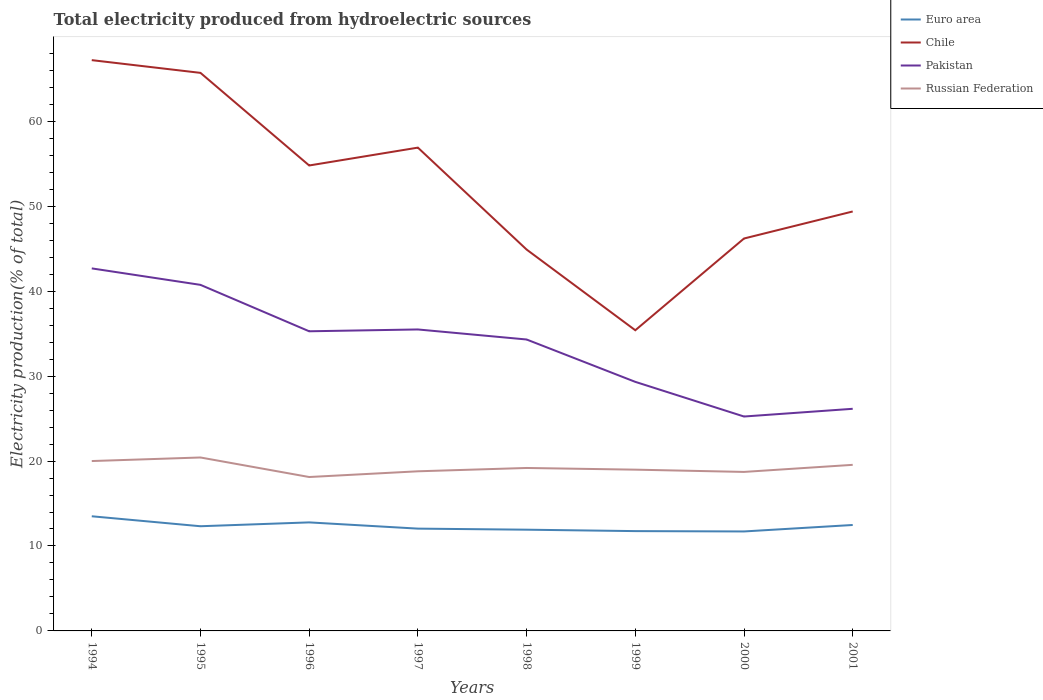How many different coloured lines are there?
Offer a very short reply. 4. Is the number of lines equal to the number of legend labels?
Make the answer very short. Yes. Across all years, what is the maximum total electricity produced in Chile?
Ensure brevity in your answer.  35.4. What is the total total electricity produced in Euro area in the graph?
Your response must be concise. 0.31. What is the difference between the highest and the second highest total electricity produced in Chile?
Keep it short and to the point. 31.8. What is the difference between the highest and the lowest total electricity produced in Pakistan?
Offer a very short reply. 5. Is the total electricity produced in Pakistan strictly greater than the total electricity produced in Euro area over the years?
Your answer should be compact. No. How many lines are there?
Keep it short and to the point. 4. Does the graph contain any zero values?
Keep it short and to the point. No. How many legend labels are there?
Give a very brief answer. 4. What is the title of the graph?
Give a very brief answer. Total electricity produced from hydroelectric sources. What is the label or title of the X-axis?
Ensure brevity in your answer.  Years. What is the label or title of the Y-axis?
Provide a succinct answer. Electricity production(% of total). What is the Electricity production(% of total) in Euro area in 1994?
Make the answer very short. 13.5. What is the Electricity production(% of total) of Chile in 1994?
Offer a very short reply. 67.2. What is the Electricity production(% of total) in Pakistan in 1994?
Keep it short and to the point. 42.68. What is the Electricity production(% of total) of Russian Federation in 1994?
Your answer should be very brief. 20. What is the Electricity production(% of total) in Euro area in 1995?
Offer a very short reply. 12.32. What is the Electricity production(% of total) of Chile in 1995?
Your response must be concise. 65.7. What is the Electricity production(% of total) in Pakistan in 1995?
Your answer should be very brief. 40.74. What is the Electricity production(% of total) in Russian Federation in 1995?
Your response must be concise. 20.42. What is the Electricity production(% of total) in Euro area in 1996?
Keep it short and to the point. 12.78. What is the Electricity production(% of total) of Chile in 1996?
Give a very brief answer. 54.8. What is the Electricity production(% of total) of Pakistan in 1996?
Ensure brevity in your answer.  35.28. What is the Electricity production(% of total) in Russian Federation in 1996?
Your response must be concise. 18.12. What is the Electricity production(% of total) in Euro area in 1997?
Provide a short and direct response. 12.04. What is the Electricity production(% of total) in Chile in 1997?
Your answer should be very brief. 56.9. What is the Electricity production(% of total) of Pakistan in 1997?
Ensure brevity in your answer.  35.49. What is the Electricity production(% of total) in Russian Federation in 1997?
Offer a terse response. 18.79. What is the Electricity production(% of total) of Euro area in 1998?
Offer a very short reply. 11.92. What is the Electricity production(% of total) in Chile in 1998?
Provide a short and direct response. 44.9. What is the Electricity production(% of total) of Pakistan in 1998?
Provide a short and direct response. 34.31. What is the Electricity production(% of total) of Russian Federation in 1998?
Offer a terse response. 19.18. What is the Electricity production(% of total) of Euro area in 1999?
Your answer should be very brief. 11.75. What is the Electricity production(% of total) of Chile in 1999?
Ensure brevity in your answer.  35.4. What is the Electricity production(% of total) of Pakistan in 1999?
Your response must be concise. 29.32. What is the Electricity production(% of total) of Russian Federation in 1999?
Ensure brevity in your answer.  18.99. What is the Electricity production(% of total) in Euro area in 2000?
Offer a terse response. 11.71. What is the Electricity production(% of total) of Chile in 2000?
Provide a succinct answer. 46.2. What is the Electricity production(% of total) in Pakistan in 2000?
Give a very brief answer. 25.24. What is the Electricity production(% of total) in Russian Federation in 2000?
Your answer should be compact. 18.72. What is the Electricity production(% of total) of Euro area in 2001?
Offer a very short reply. 12.47. What is the Electricity production(% of total) in Chile in 2001?
Make the answer very short. 49.38. What is the Electricity production(% of total) of Pakistan in 2001?
Provide a short and direct response. 26.15. What is the Electricity production(% of total) in Russian Federation in 2001?
Give a very brief answer. 19.55. Across all years, what is the maximum Electricity production(% of total) of Euro area?
Keep it short and to the point. 13.5. Across all years, what is the maximum Electricity production(% of total) in Chile?
Provide a succinct answer. 67.2. Across all years, what is the maximum Electricity production(% of total) of Pakistan?
Offer a terse response. 42.68. Across all years, what is the maximum Electricity production(% of total) of Russian Federation?
Ensure brevity in your answer.  20.42. Across all years, what is the minimum Electricity production(% of total) of Euro area?
Keep it short and to the point. 11.71. Across all years, what is the minimum Electricity production(% of total) of Chile?
Your answer should be very brief. 35.4. Across all years, what is the minimum Electricity production(% of total) in Pakistan?
Offer a terse response. 25.24. Across all years, what is the minimum Electricity production(% of total) of Russian Federation?
Provide a short and direct response. 18.12. What is the total Electricity production(% of total) in Euro area in the graph?
Provide a succinct answer. 98.5. What is the total Electricity production(% of total) in Chile in the graph?
Your answer should be compact. 420.48. What is the total Electricity production(% of total) of Pakistan in the graph?
Ensure brevity in your answer.  269.22. What is the total Electricity production(% of total) in Russian Federation in the graph?
Make the answer very short. 153.78. What is the difference between the Electricity production(% of total) of Euro area in 1994 and that in 1995?
Keep it short and to the point. 1.17. What is the difference between the Electricity production(% of total) in Chile in 1994 and that in 1995?
Your answer should be very brief. 1.5. What is the difference between the Electricity production(% of total) in Pakistan in 1994 and that in 1995?
Make the answer very short. 1.94. What is the difference between the Electricity production(% of total) in Russian Federation in 1994 and that in 1995?
Your answer should be compact. -0.42. What is the difference between the Electricity production(% of total) of Euro area in 1994 and that in 1996?
Keep it short and to the point. 0.72. What is the difference between the Electricity production(% of total) of Chile in 1994 and that in 1996?
Give a very brief answer. 12.4. What is the difference between the Electricity production(% of total) in Pakistan in 1994 and that in 1996?
Offer a very short reply. 7.4. What is the difference between the Electricity production(% of total) in Russian Federation in 1994 and that in 1996?
Offer a terse response. 1.88. What is the difference between the Electricity production(% of total) of Euro area in 1994 and that in 1997?
Provide a short and direct response. 1.45. What is the difference between the Electricity production(% of total) of Chile in 1994 and that in 1997?
Ensure brevity in your answer.  10.3. What is the difference between the Electricity production(% of total) of Pakistan in 1994 and that in 1997?
Provide a succinct answer. 7.19. What is the difference between the Electricity production(% of total) in Russian Federation in 1994 and that in 1997?
Your response must be concise. 1.21. What is the difference between the Electricity production(% of total) of Euro area in 1994 and that in 1998?
Offer a terse response. 1.58. What is the difference between the Electricity production(% of total) of Chile in 1994 and that in 1998?
Make the answer very short. 22.3. What is the difference between the Electricity production(% of total) in Pakistan in 1994 and that in 1998?
Your answer should be compact. 8.37. What is the difference between the Electricity production(% of total) in Russian Federation in 1994 and that in 1998?
Ensure brevity in your answer.  0.82. What is the difference between the Electricity production(% of total) of Euro area in 1994 and that in 1999?
Make the answer very short. 1.75. What is the difference between the Electricity production(% of total) in Chile in 1994 and that in 1999?
Ensure brevity in your answer.  31.8. What is the difference between the Electricity production(% of total) of Pakistan in 1994 and that in 1999?
Provide a short and direct response. 13.36. What is the difference between the Electricity production(% of total) in Russian Federation in 1994 and that in 1999?
Ensure brevity in your answer.  1.01. What is the difference between the Electricity production(% of total) of Euro area in 1994 and that in 2000?
Ensure brevity in your answer.  1.79. What is the difference between the Electricity production(% of total) in Chile in 1994 and that in 2000?
Provide a short and direct response. 21. What is the difference between the Electricity production(% of total) of Pakistan in 1994 and that in 2000?
Provide a short and direct response. 17.44. What is the difference between the Electricity production(% of total) of Russian Federation in 1994 and that in 2000?
Offer a very short reply. 1.28. What is the difference between the Electricity production(% of total) in Euro area in 1994 and that in 2001?
Give a very brief answer. 1.03. What is the difference between the Electricity production(% of total) of Chile in 1994 and that in 2001?
Your answer should be compact. 17.82. What is the difference between the Electricity production(% of total) in Pakistan in 1994 and that in 2001?
Offer a very short reply. 16.53. What is the difference between the Electricity production(% of total) of Russian Federation in 1994 and that in 2001?
Keep it short and to the point. 0.45. What is the difference between the Electricity production(% of total) in Euro area in 1995 and that in 1996?
Make the answer very short. -0.45. What is the difference between the Electricity production(% of total) in Chile in 1995 and that in 1996?
Keep it short and to the point. 10.9. What is the difference between the Electricity production(% of total) of Pakistan in 1995 and that in 1996?
Your answer should be very brief. 5.47. What is the difference between the Electricity production(% of total) of Russian Federation in 1995 and that in 1996?
Your response must be concise. 2.3. What is the difference between the Electricity production(% of total) in Euro area in 1995 and that in 1997?
Offer a very short reply. 0.28. What is the difference between the Electricity production(% of total) in Chile in 1995 and that in 1997?
Ensure brevity in your answer.  8.8. What is the difference between the Electricity production(% of total) of Pakistan in 1995 and that in 1997?
Provide a short and direct response. 5.25. What is the difference between the Electricity production(% of total) of Russian Federation in 1995 and that in 1997?
Give a very brief answer. 1.63. What is the difference between the Electricity production(% of total) of Euro area in 1995 and that in 1998?
Provide a short and direct response. 0.41. What is the difference between the Electricity production(% of total) in Chile in 1995 and that in 1998?
Offer a terse response. 20.8. What is the difference between the Electricity production(% of total) in Pakistan in 1995 and that in 1998?
Ensure brevity in your answer.  6.43. What is the difference between the Electricity production(% of total) of Russian Federation in 1995 and that in 1998?
Ensure brevity in your answer.  1.24. What is the difference between the Electricity production(% of total) of Euro area in 1995 and that in 1999?
Your response must be concise. 0.57. What is the difference between the Electricity production(% of total) of Chile in 1995 and that in 1999?
Your answer should be very brief. 30.3. What is the difference between the Electricity production(% of total) of Pakistan in 1995 and that in 1999?
Your answer should be very brief. 11.42. What is the difference between the Electricity production(% of total) in Russian Federation in 1995 and that in 1999?
Make the answer very short. 1.43. What is the difference between the Electricity production(% of total) of Euro area in 1995 and that in 2000?
Offer a terse response. 0.61. What is the difference between the Electricity production(% of total) of Chile in 1995 and that in 2000?
Provide a succinct answer. 19.5. What is the difference between the Electricity production(% of total) of Pakistan in 1995 and that in 2000?
Provide a succinct answer. 15.5. What is the difference between the Electricity production(% of total) in Russian Federation in 1995 and that in 2000?
Offer a terse response. 1.7. What is the difference between the Electricity production(% of total) in Euro area in 1995 and that in 2001?
Make the answer very short. -0.15. What is the difference between the Electricity production(% of total) in Chile in 1995 and that in 2001?
Offer a very short reply. 16.32. What is the difference between the Electricity production(% of total) of Pakistan in 1995 and that in 2001?
Your answer should be very brief. 14.59. What is the difference between the Electricity production(% of total) in Russian Federation in 1995 and that in 2001?
Keep it short and to the point. 0.87. What is the difference between the Electricity production(% of total) in Euro area in 1996 and that in 1997?
Offer a very short reply. 0.73. What is the difference between the Electricity production(% of total) in Chile in 1996 and that in 1997?
Make the answer very short. -2.1. What is the difference between the Electricity production(% of total) of Pakistan in 1996 and that in 1997?
Make the answer very short. -0.21. What is the difference between the Electricity production(% of total) in Russian Federation in 1996 and that in 1997?
Your answer should be compact. -0.67. What is the difference between the Electricity production(% of total) in Euro area in 1996 and that in 1998?
Keep it short and to the point. 0.86. What is the difference between the Electricity production(% of total) in Chile in 1996 and that in 1998?
Offer a terse response. 9.9. What is the difference between the Electricity production(% of total) in Pakistan in 1996 and that in 1998?
Your answer should be very brief. 0.97. What is the difference between the Electricity production(% of total) of Russian Federation in 1996 and that in 1998?
Offer a terse response. -1.06. What is the difference between the Electricity production(% of total) of Euro area in 1996 and that in 1999?
Provide a succinct answer. 1.03. What is the difference between the Electricity production(% of total) of Chile in 1996 and that in 1999?
Offer a terse response. 19.4. What is the difference between the Electricity production(% of total) of Pakistan in 1996 and that in 1999?
Provide a short and direct response. 5.96. What is the difference between the Electricity production(% of total) of Russian Federation in 1996 and that in 1999?
Your answer should be compact. -0.86. What is the difference between the Electricity production(% of total) of Euro area in 1996 and that in 2000?
Make the answer very short. 1.07. What is the difference between the Electricity production(% of total) in Chile in 1996 and that in 2000?
Offer a very short reply. 8.6. What is the difference between the Electricity production(% of total) of Pakistan in 1996 and that in 2000?
Your response must be concise. 10.04. What is the difference between the Electricity production(% of total) in Russian Federation in 1996 and that in 2000?
Ensure brevity in your answer.  -0.6. What is the difference between the Electricity production(% of total) in Euro area in 1996 and that in 2001?
Offer a terse response. 0.31. What is the difference between the Electricity production(% of total) of Chile in 1996 and that in 2001?
Offer a terse response. 5.42. What is the difference between the Electricity production(% of total) of Pakistan in 1996 and that in 2001?
Ensure brevity in your answer.  9.13. What is the difference between the Electricity production(% of total) in Russian Federation in 1996 and that in 2001?
Give a very brief answer. -1.43. What is the difference between the Electricity production(% of total) in Euro area in 1997 and that in 1998?
Offer a very short reply. 0.13. What is the difference between the Electricity production(% of total) in Chile in 1997 and that in 1998?
Provide a succinct answer. 12. What is the difference between the Electricity production(% of total) in Pakistan in 1997 and that in 1998?
Offer a terse response. 1.18. What is the difference between the Electricity production(% of total) of Russian Federation in 1997 and that in 1998?
Offer a very short reply. -0.39. What is the difference between the Electricity production(% of total) in Euro area in 1997 and that in 1999?
Offer a very short reply. 0.29. What is the difference between the Electricity production(% of total) in Chile in 1997 and that in 1999?
Your answer should be compact. 21.5. What is the difference between the Electricity production(% of total) in Pakistan in 1997 and that in 1999?
Keep it short and to the point. 6.17. What is the difference between the Electricity production(% of total) in Russian Federation in 1997 and that in 1999?
Offer a terse response. -0.19. What is the difference between the Electricity production(% of total) in Euro area in 1997 and that in 2000?
Your answer should be very brief. 0.33. What is the difference between the Electricity production(% of total) of Chile in 1997 and that in 2000?
Offer a very short reply. 10.7. What is the difference between the Electricity production(% of total) in Pakistan in 1997 and that in 2000?
Ensure brevity in your answer.  10.25. What is the difference between the Electricity production(% of total) in Russian Federation in 1997 and that in 2000?
Your answer should be very brief. 0.07. What is the difference between the Electricity production(% of total) of Euro area in 1997 and that in 2001?
Offer a very short reply. -0.43. What is the difference between the Electricity production(% of total) of Chile in 1997 and that in 2001?
Your response must be concise. 7.52. What is the difference between the Electricity production(% of total) of Pakistan in 1997 and that in 2001?
Provide a succinct answer. 9.34. What is the difference between the Electricity production(% of total) of Russian Federation in 1997 and that in 2001?
Give a very brief answer. -0.76. What is the difference between the Electricity production(% of total) of Euro area in 1998 and that in 1999?
Your response must be concise. 0.17. What is the difference between the Electricity production(% of total) of Chile in 1998 and that in 1999?
Keep it short and to the point. 9.5. What is the difference between the Electricity production(% of total) in Pakistan in 1998 and that in 1999?
Offer a very short reply. 4.99. What is the difference between the Electricity production(% of total) in Russian Federation in 1998 and that in 1999?
Provide a succinct answer. 0.2. What is the difference between the Electricity production(% of total) of Euro area in 1998 and that in 2000?
Ensure brevity in your answer.  0.21. What is the difference between the Electricity production(% of total) in Chile in 1998 and that in 2000?
Your answer should be compact. -1.3. What is the difference between the Electricity production(% of total) of Pakistan in 1998 and that in 2000?
Offer a very short reply. 9.07. What is the difference between the Electricity production(% of total) in Russian Federation in 1998 and that in 2000?
Your answer should be compact. 0.46. What is the difference between the Electricity production(% of total) of Euro area in 1998 and that in 2001?
Offer a terse response. -0.55. What is the difference between the Electricity production(% of total) of Chile in 1998 and that in 2001?
Your answer should be compact. -4.48. What is the difference between the Electricity production(% of total) of Pakistan in 1998 and that in 2001?
Keep it short and to the point. 8.16. What is the difference between the Electricity production(% of total) in Russian Federation in 1998 and that in 2001?
Make the answer very short. -0.37. What is the difference between the Electricity production(% of total) of Euro area in 1999 and that in 2000?
Keep it short and to the point. 0.04. What is the difference between the Electricity production(% of total) in Chile in 1999 and that in 2000?
Offer a terse response. -10.8. What is the difference between the Electricity production(% of total) in Pakistan in 1999 and that in 2000?
Offer a very short reply. 4.08. What is the difference between the Electricity production(% of total) of Russian Federation in 1999 and that in 2000?
Ensure brevity in your answer.  0.27. What is the difference between the Electricity production(% of total) of Euro area in 1999 and that in 2001?
Provide a short and direct response. -0.72. What is the difference between the Electricity production(% of total) in Chile in 1999 and that in 2001?
Keep it short and to the point. -13.98. What is the difference between the Electricity production(% of total) of Pakistan in 1999 and that in 2001?
Your answer should be very brief. 3.17. What is the difference between the Electricity production(% of total) in Russian Federation in 1999 and that in 2001?
Your response must be concise. -0.57. What is the difference between the Electricity production(% of total) in Euro area in 2000 and that in 2001?
Provide a succinct answer. -0.76. What is the difference between the Electricity production(% of total) in Chile in 2000 and that in 2001?
Give a very brief answer. -3.18. What is the difference between the Electricity production(% of total) in Pakistan in 2000 and that in 2001?
Give a very brief answer. -0.91. What is the difference between the Electricity production(% of total) in Russian Federation in 2000 and that in 2001?
Provide a succinct answer. -0.83. What is the difference between the Electricity production(% of total) of Euro area in 1994 and the Electricity production(% of total) of Chile in 1995?
Keep it short and to the point. -52.2. What is the difference between the Electricity production(% of total) of Euro area in 1994 and the Electricity production(% of total) of Pakistan in 1995?
Offer a terse response. -27.25. What is the difference between the Electricity production(% of total) in Euro area in 1994 and the Electricity production(% of total) in Russian Federation in 1995?
Make the answer very short. -6.92. What is the difference between the Electricity production(% of total) in Chile in 1994 and the Electricity production(% of total) in Pakistan in 1995?
Your answer should be very brief. 26.46. What is the difference between the Electricity production(% of total) in Chile in 1994 and the Electricity production(% of total) in Russian Federation in 1995?
Provide a succinct answer. 46.78. What is the difference between the Electricity production(% of total) in Pakistan in 1994 and the Electricity production(% of total) in Russian Federation in 1995?
Your answer should be compact. 22.26. What is the difference between the Electricity production(% of total) of Euro area in 1994 and the Electricity production(% of total) of Chile in 1996?
Provide a short and direct response. -41.3. What is the difference between the Electricity production(% of total) in Euro area in 1994 and the Electricity production(% of total) in Pakistan in 1996?
Your answer should be compact. -21.78. What is the difference between the Electricity production(% of total) of Euro area in 1994 and the Electricity production(% of total) of Russian Federation in 1996?
Ensure brevity in your answer.  -4.62. What is the difference between the Electricity production(% of total) in Chile in 1994 and the Electricity production(% of total) in Pakistan in 1996?
Provide a succinct answer. 31.92. What is the difference between the Electricity production(% of total) in Chile in 1994 and the Electricity production(% of total) in Russian Federation in 1996?
Your answer should be compact. 49.08. What is the difference between the Electricity production(% of total) in Pakistan in 1994 and the Electricity production(% of total) in Russian Federation in 1996?
Your answer should be very brief. 24.56. What is the difference between the Electricity production(% of total) of Euro area in 1994 and the Electricity production(% of total) of Chile in 1997?
Provide a succinct answer. -43.4. What is the difference between the Electricity production(% of total) in Euro area in 1994 and the Electricity production(% of total) in Pakistan in 1997?
Provide a short and direct response. -21.99. What is the difference between the Electricity production(% of total) of Euro area in 1994 and the Electricity production(% of total) of Russian Federation in 1997?
Your answer should be very brief. -5.3. What is the difference between the Electricity production(% of total) of Chile in 1994 and the Electricity production(% of total) of Pakistan in 1997?
Provide a short and direct response. 31.71. What is the difference between the Electricity production(% of total) of Chile in 1994 and the Electricity production(% of total) of Russian Federation in 1997?
Your answer should be very brief. 48.41. What is the difference between the Electricity production(% of total) in Pakistan in 1994 and the Electricity production(% of total) in Russian Federation in 1997?
Provide a succinct answer. 23.89. What is the difference between the Electricity production(% of total) in Euro area in 1994 and the Electricity production(% of total) in Chile in 1998?
Give a very brief answer. -31.4. What is the difference between the Electricity production(% of total) in Euro area in 1994 and the Electricity production(% of total) in Pakistan in 1998?
Your response must be concise. -20.81. What is the difference between the Electricity production(% of total) in Euro area in 1994 and the Electricity production(% of total) in Russian Federation in 1998?
Offer a very short reply. -5.69. What is the difference between the Electricity production(% of total) of Chile in 1994 and the Electricity production(% of total) of Pakistan in 1998?
Your answer should be very brief. 32.89. What is the difference between the Electricity production(% of total) in Chile in 1994 and the Electricity production(% of total) in Russian Federation in 1998?
Give a very brief answer. 48.02. What is the difference between the Electricity production(% of total) of Pakistan in 1994 and the Electricity production(% of total) of Russian Federation in 1998?
Offer a very short reply. 23.5. What is the difference between the Electricity production(% of total) of Euro area in 1994 and the Electricity production(% of total) of Chile in 1999?
Give a very brief answer. -21.9. What is the difference between the Electricity production(% of total) of Euro area in 1994 and the Electricity production(% of total) of Pakistan in 1999?
Make the answer very short. -15.82. What is the difference between the Electricity production(% of total) of Euro area in 1994 and the Electricity production(% of total) of Russian Federation in 1999?
Give a very brief answer. -5.49. What is the difference between the Electricity production(% of total) of Chile in 1994 and the Electricity production(% of total) of Pakistan in 1999?
Your response must be concise. 37.88. What is the difference between the Electricity production(% of total) in Chile in 1994 and the Electricity production(% of total) in Russian Federation in 1999?
Provide a succinct answer. 48.21. What is the difference between the Electricity production(% of total) in Pakistan in 1994 and the Electricity production(% of total) in Russian Federation in 1999?
Keep it short and to the point. 23.7. What is the difference between the Electricity production(% of total) in Euro area in 1994 and the Electricity production(% of total) in Chile in 2000?
Offer a very short reply. -32.7. What is the difference between the Electricity production(% of total) in Euro area in 1994 and the Electricity production(% of total) in Pakistan in 2000?
Ensure brevity in your answer.  -11.74. What is the difference between the Electricity production(% of total) of Euro area in 1994 and the Electricity production(% of total) of Russian Federation in 2000?
Offer a very short reply. -5.22. What is the difference between the Electricity production(% of total) of Chile in 1994 and the Electricity production(% of total) of Pakistan in 2000?
Your answer should be very brief. 41.96. What is the difference between the Electricity production(% of total) in Chile in 1994 and the Electricity production(% of total) in Russian Federation in 2000?
Give a very brief answer. 48.48. What is the difference between the Electricity production(% of total) of Pakistan in 1994 and the Electricity production(% of total) of Russian Federation in 2000?
Your response must be concise. 23.96. What is the difference between the Electricity production(% of total) of Euro area in 1994 and the Electricity production(% of total) of Chile in 2001?
Keep it short and to the point. -35.89. What is the difference between the Electricity production(% of total) in Euro area in 1994 and the Electricity production(% of total) in Pakistan in 2001?
Ensure brevity in your answer.  -12.65. What is the difference between the Electricity production(% of total) of Euro area in 1994 and the Electricity production(% of total) of Russian Federation in 2001?
Give a very brief answer. -6.06. What is the difference between the Electricity production(% of total) in Chile in 1994 and the Electricity production(% of total) in Pakistan in 2001?
Offer a very short reply. 41.05. What is the difference between the Electricity production(% of total) in Chile in 1994 and the Electricity production(% of total) in Russian Federation in 2001?
Keep it short and to the point. 47.65. What is the difference between the Electricity production(% of total) in Pakistan in 1994 and the Electricity production(% of total) in Russian Federation in 2001?
Your answer should be very brief. 23.13. What is the difference between the Electricity production(% of total) of Euro area in 1995 and the Electricity production(% of total) of Chile in 1996?
Your answer should be very brief. -42.47. What is the difference between the Electricity production(% of total) of Euro area in 1995 and the Electricity production(% of total) of Pakistan in 1996?
Your answer should be compact. -22.95. What is the difference between the Electricity production(% of total) in Euro area in 1995 and the Electricity production(% of total) in Russian Federation in 1996?
Your response must be concise. -5.8. What is the difference between the Electricity production(% of total) of Chile in 1995 and the Electricity production(% of total) of Pakistan in 1996?
Offer a terse response. 30.42. What is the difference between the Electricity production(% of total) of Chile in 1995 and the Electricity production(% of total) of Russian Federation in 1996?
Keep it short and to the point. 47.58. What is the difference between the Electricity production(% of total) of Pakistan in 1995 and the Electricity production(% of total) of Russian Federation in 1996?
Offer a very short reply. 22.62. What is the difference between the Electricity production(% of total) in Euro area in 1995 and the Electricity production(% of total) in Chile in 1997?
Your answer should be very brief. -44.58. What is the difference between the Electricity production(% of total) of Euro area in 1995 and the Electricity production(% of total) of Pakistan in 1997?
Your answer should be compact. -23.17. What is the difference between the Electricity production(% of total) of Euro area in 1995 and the Electricity production(% of total) of Russian Federation in 1997?
Your answer should be compact. -6.47. What is the difference between the Electricity production(% of total) of Chile in 1995 and the Electricity production(% of total) of Pakistan in 1997?
Give a very brief answer. 30.21. What is the difference between the Electricity production(% of total) in Chile in 1995 and the Electricity production(% of total) in Russian Federation in 1997?
Your answer should be very brief. 46.91. What is the difference between the Electricity production(% of total) in Pakistan in 1995 and the Electricity production(% of total) in Russian Federation in 1997?
Provide a short and direct response. 21.95. What is the difference between the Electricity production(% of total) of Euro area in 1995 and the Electricity production(% of total) of Chile in 1998?
Your answer should be very brief. -32.58. What is the difference between the Electricity production(% of total) of Euro area in 1995 and the Electricity production(% of total) of Pakistan in 1998?
Make the answer very short. -21.99. What is the difference between the Electricity production(% of total) of Euro area in 1995 and the Electricity production(% of total) of Russian Federation in 1998?
Make the answer very short. -6.86. What is the difference between the Electricity production(% of total) of Chile in 1995 and the Electricity production(% of total) of Pakistan in 1998?
Offer a very short reply. 31.39. What is the difference between the Electricity production(% of total) of Chile in 1995 and the Electricity production(% of total) of Russian Federation in 1998?
Keep it short and to the point. 46.52. What is the difference between the Electricity production(% of total) in Pakistan in 1995 and the Electricity production(% of total) in Russian Federation in 1998?
Your answer should be very brief. 21.56. What is the difference between the Electricity production(% of total) in Euro area in 1995 and the Electricity production(% of total) in Chile in 1999?
Offer a very short reply. -23.08. What is the difference between the Electricity production(% of total) in Euro area in 1995 and the Electricity production(% of total) in Pakistan in 1999?
Give a very brief answer. -17. What is the difference between the Electricity production(% of total) of Euro area in 1995 and the Electricity production(% of total) of Russian Federation in 1999?
Your answer should be very brief. -6.66. What is the difference between the Electricity production(% of total) of Chile in 1995 and the Electricity production(% of total) of Pakistan in 1999?
Your answer should be very brief. 36.38. What is the difference between the Electricity production(% of total) in Chile in 1995 and the Electricity production(% of total) in Russian Federation in 1999?
Offer a very short reply. 46.72. What is the difference between the Electricity production(% of total) in Pakistan in 1995 and the Electricity production(% of total) in Russian Federation in 1999?
Your answer should be very brief. 21.76. What is the difference between the Electricity production(% of total) of Euro area in 1995 and the Electricity production(% of total) of Chile in 2000?
Provide a succinct answer. -33.88. What is the difference between the Electricity production(% of total) in Euro area in 1995 and the Electricity production(% of total) in Pakistan in 2000?
Offer a terse response. -12.92. What is the difference between the Electricity production(% of total) of Euro area in 1995 and the Electricity production(% of total) of Russian Federation in 2000?
Keep it short and to the point. -6.4. What is the difference between the Electricity production(% of total) of Chile in 1995 and the Electricity production(% of total) of Pakistan in 2000?
Your response must be concise. 40.46. What is the difference between the Electricity production(% of total) in Chile in 1995 and the Electricity production(% of total) in Russian Federation in 2000?
Make the answer very short. 46.98. What is the difference between the Electricity production(% of total) in Pakistan in 1995 and the Electricity production(% of total) in Russian Federation in 2000?
Your answer should be compact. 22.02. What is the difference between the Electricity production(% of total) in Euro area in 1995 and the Electricity production(% of total) in Chile in 2001?
Offer a very short reply. -37.06. What is the difference between the Electricity production(% of total) in Euro area in 1995 and the Electricity production(% of total) in Pakistan in 2001?
Ensure brevity in your answer.  -13.83. What is the difference between the Electricity production(% of total) in Euro area in 1995 and the Electricity production(% of total) in Russian Federation in 2001?
Provide a succinct answer. -7.23. What is the difference between the Electricity production(% of total) of Chile in 1995 and the Electricity production(% of total) of Pakistan in 2001?
Your answer should be compact. 39.55. What is the difference between the Electricity production(% of total) of Chile in 1995 and the Electricity production(% of total) of Russian Federation in 2001?
Make the answer very short. 46.15. What is the difference between the Electricity production(% of total) in Pakistan in 1995 and the Electricity production(% of total) in Russian Federation in 2001?
Offer a terse response. 21.19. What is the difference between the Electricity production(% of total) of Euro area in 1996 and the Electricity production(% of total) of Chile in 1997?
Give a very brief answer. -44.12. What is the difference between the Electricity production(% of total) in Euro area in 1996 and the Electricity production(% of total) in Pakistan in 1997?
Your answer should be compact. -22.71. What is the difference between the Electricity production(% of total) of Euro area in 1996 and the Electricity production(% of total) of Russian Federation in 1997?
Give a very brief answer. -6.02. What is the difference between the Electricity production(% of total) of Chile in 1996 and the Electricity production(% of total) of Pakistan in 1997?
Ensure brevity in your answer.  19.31. What is the difference between the Electricity production(% of total) in Chile in 1996 and the Electricity production(% of total) in Russian Federation in 1997?
Make the answer very short. 36. What is the difference between the Electricity production(% of total) in Pakistan in 1996 and the Electricity production(% of total) in Russian Federation in 1997?
Keep it short and to the point. 16.48. What is the difference between the Electricity production(% of total) in Euro area in 1996 and the Electricity production(% of total) in Chile in 1998?
Your answer should be very brief. -32.12. What is the difference between the Electricity production(% of total) in Euro area in 1996 and the Electricity production(% of total) in Pakistan in 1998?
Your answer should be very brief. -21.53. What is the difference between the Electricity production(% of total) in Euro area in 1996 and the Electricity production(% of total) in Russian Federation in 1998?
Your answer should be very brief. -6.41. What is the difference between the Electricity production(% of total) of Chile in 1996 and the Electricity production(% of total) of Pakistan in 1998?
Provide a short and direct response. 20.49. What is the difference between the Electricity production(% of total) of Chile in 1996 and the Electricity production(% of total) of Russian Federation in 1998?
Give a very brief answer. 35.61. What is the difference between the Electricity production(% of total) of Pakistan in 1996 and the Electricity production(% of total) of Russian Federation in 1998?
Provide a short and direct response. 16.09. What is the difference between the Electricity production(% of total) of Euro area in 1996 and the Electricity production(% of total) of Chile in 1999?
Keep it short and to the point. -22.62. What is the difference between the Electricity production(% of total) in Euro area in 1996 and the Electricity production(% of total) in Pakistan in 1999?
Provide a succinct answer. -16.54. What is the difference between the Electricity production(% of total) in Euro area in 1996 and the Electricity production(% of total) in Russian Federation in 1999?
Ensure brevity in your answer.  -6.21. What is the difference between the Electricity production(% of total) of Chile in 1996 and the Electricity production(% of total) of Pakistan in 1999?
Give a very brief answer. 25.48. What is the difference between the Electricity production(% of total) of Chile in 1996 and the Electricity production(% of total) of Russian Federation in 1999?
Keep it short and to the point. 35.81. What is the difference between the Electricity production(% of total) in Pakistan in 1996 and the Electricity production(% of total) in Russian Federation in 1999?
Offer a terse response. 16.29. What is the difference between the Electricity production(% of total) of Euro area in 1996 and the Electricity production(% of total) of Chile in 2000?
Give a very brief answer. -33.42. What is the difference between the Electricity production(% of total) of Euro area in 1996 and the Electricity production(% of total) of Pakistan in 2000?
Your answer should be compact. -12.46. What is the difference between the Electricity production(% of total) of Euro area in 1996 and the Electricity production(% of total) of Russian Federation in 2000?
Offer a very short reply. -5.94. What is the difference between the Electricity production(% of total) of Chile in 1996 and the Electricity production(% of total) of Pakistan in 2000?
Your answer should be very brief. 29.56. What is the difference between the Electricity production(% of total) in Chile in 1996 and the Electricity production(% of total) in Russian Federation in 2000?
Offer a very short reply. 36.08. What is the difference between the Electricity production(% of total) of Pakistan in 1996 and the Electricity production(% of total) of Russian Federation in 2000?
Provide a succinct answer. 16.56. What is the difference between the Electricity production(% of total) in Euro area in 1996 and the Electricity production(% of total) in Chile in 2001?
Your answer should be compact. -36.6. What is the difference between the Electricity production(% of total) in Euro area in 1996 and the Electricity production(% of total) in Pakistan in 2001?
Provide a short and direct response. -13.37. What is the difference between the Electricity production(% of total) of Euro area in 1996 and the Electricity production(% of total) of Russian Federation in 2001?
Ensure brevity in your answer.  -6.78. What is the difference between the Electricity production(% of total) in Chile in 1996 and the Electricity production(% of total) in Pakistan in 2001?
Provide a succinct answer. 28.65. What is the difference between the Electricity production(% of total) in Chile in 1996 and the Electricity production(% of total) in Russian Federation in 2001?
Make the answer very short. 35.24. What is the difference between the Electricity production(% of total) in Pakistan in 1996 and the Electricity production(% of total) in Russian Federation in 2001?
Offer a terse response. 15.72. What is the difference between the Electricity production(% of total) of Euro area in 1997 and the Electricity production(% of total) of Chile in 1998?
Offer a very short reply. -32.86. What is the difference between the Electricity production(% of total) in Euro area in 1997 and the Electricity production(% of total) in Pakistan in 1998?
Ensure brevity in your answer.  -22.27. What is the difference between the Electricity production(% of total) of Euro area in 1997 and the Electricity production(% of total) of Russian Federation in 1998?
Your answer should be very brief. -7.14. What is the difference between the Electricity production(% of total) of Chile in 1997 and the Electricity production(% of total) of Pakistan in 1998?
Your response must be concise. 22.59. What is the difference between the Electricity production(% of total) in Chile in 1997 and the Electricity production(% of total) in Russian Federation in 1998?
Provide a succinct answer. 37.72. What is the difference between the Electricity production(% of total) of Pakistan in 1997 and the Electricity production(% of total) of Russian Federation in 1998?
Make the answer very short. 16.31. What is the difference between the Electricity production(% of total) in Euro area in 1997 and the Electricity production(% of total) in Chile in 1999?
Ensure brevity in your answer.  -23.36. What is the difference between the Electricity production(% of total) in Euro area in 1997 and the Electricity production(% of total) in Pakistan in 1999?
Your answer should be very brief. -17.28. What is the difference between the Electricity production(% of total) in Euro area in 1997 and the Electricity production(% of total) in Russian Federation in 1999?
Your answer should be very brief. -6.94. What is the difference between the Electricity production(% of total) of Chile in 1997 and the Electricity production(% of total) of Pakistan in 1999?
Make the answer very short. 27.58. What is the difference between the Electricity production(% of total) in Chile in 1997 and the Electricity production(% of total) in Russian Federation in 1999?
Give a very brief answer. 37.91. What is the difference between the Electricity production(% of total) of Pakistan in 1997 and the Electricity production(% of total) of Russian Federation in 1999?
Provide a succinct answer. 16.51. What is the difference between the Electricity production(% of total) of Euro area in 1997 and the Electricity production(% of total) of Chile in 2000?
Provide a short and direct response. -34.16. What is the difference between the Electricity production(% of total) of Euro area in 1997 and the Electricity production(% of total) of Pakistan in 2000?
Provide a succinct answer. -13.2. What is the difference between the Electricity production(% of total) of Euro area in 1997 and the Electricity production(% of total) of Russian Federation in 2000?
Ensure brevity in your answer.  -6.68. What is the difference between the Electricity production(% of total) in Chile in 1997 and the Electricity production(% of total) in Pakistan in 2000?
Give a very brief answer. 31.66. What is the difference between the Electricity production(% of total) in Chile in 1997 and the Electricity production(% of total) in Russian Federation in 2000?
Ensure brevity in your answer.  38.18. What is the difference between the Electricity production(% of total) in Pakistan in 1997 and the Electricity production(% of total) in Russian Federation in 2000?
Ensure brevity in your answer.  16.77. What is the difference between the Electricity production(% of total) of Euro area in 1997 and the Electricity production(% of total) of Chile in 2001?
Your answer should be very brief. -37.34. What is the difference between the Electricity production(% of total) in Euro area in 1997 and the Electricity production(% of total) in Pakistan in 2001?
Offer a terse response. -14.11. What is the difference between the Electricity production(% of total) of Euro area in 1997 and the Electricity production(% of total) of Russian Federation in 2001?
Provide a short and direct response. -7.51. What is the difference between the Electricity production(% of total) of Chile in 1997 and the Electricity production(% of total) of Pakistan in 2001?
Provide a short and direct response. 30.75. What is the difference between the Electricity production(% of total) of Chile in 1997 and the Electricity production(% of total) of Russian Federation in 2001?
Ensure brevity in your answer.  37.35. What is the difference between the Electricity production(% of total) in Pakistan in 1997 and the Electricity production(% of total) in Russian Federation in 2001?
Make the answer very short. 15.94. What is the difference between the Electricity production(% of total) of Euro area in 1998 and the Electricity production(% of total) of Chile in 1999?
Provide a short and direct response. -23.48. What is the difference between the Electricity production(% of total) of Euro area in 1998 and the Electricity production(% of total) of Pakistan in 1999?
Provide a short and direct response. -17.4. What is the difference between the Electricity production(% of total) of Euro area in 1998 and the Electricity production(% of total) of Russian Federation in 1999?
Provide a short and direct response. -7.07. What is the difference between the Electricity production(% of total) of Chile in 1998 and the Electricity production(% of total) of Pakistan in 1999?
Your answer should be very brief. 15.58. What is the difference between the Electricity production(% of total) of Chile in 1998 and the Electricity production(% of total) of Russian Federation in 1999?
Offer a terse response. 25.92. What is the difference between the Electricity production(% of total) in Pakistan in 1998 and the Electricity production(% of total) in Russian Federation in 1999?
Your answer should be very brief. 15.33. What is the difference between the Electricity production(% of total) of Euro area in 1998 and the Electricity production(% of total) of Chile in 2000?
Your answer should be very brief. -34.28. What is the difference between the Electricity production(% of total) of Euro area in 1998 and the Electricity production(% of total) of Pakistan in 2000?
Keep it short and to the point. -13.32. What is the difference between the Electricity production(% of total) in Euro area in 1998 and the Electricity production(% of total) in Russian Federation in 2000?
Provide a short and direct response. -6.8. What is the difference between the Electricity production(% of total) of Chile in 1998 and the Electricity production(% of total) of Pakistan in 2000?
Make the answer very short. 19.66. What is the difference between the Electricity production(% of total) of Chile in 1998 and the Electricity production(% of total) of Russian Federation in 2000?
Ensure brevity in your answer.  26.18. What is the difference between the Electricity production(% of total) in Pakistan in 1998 and the Electricity production(% of total) in Russian Federation in 2000?
Give a very brief answer. 15.59. What is the difference between the Electricity production(% of total) of Euro area in 1998 and the Electricity production(% of total) of Chile in 2001?
Your response must be concise. -37.46. What is the difference between the Electricity production(% of total) of Euro area in 1998 and the Electricity production(% of total) of Pakistan in 2001?
Make the answer very short. -14.23. What is the difference between the Electricity production(% of total) in Euro area in 1998 and the Electricity production(% of total) in Russian Federation in 2001?
Offer a very short reply. -7.64. What is the difference between the Electricity production(% of total) of Chile in 1998 and the Electricity production(% of total) of Pakistan in 2001?
Keep it short and to the point. 18.75. What is the difference between the Electricity production(% of total) of Chile in 1998 and the Electricity production(% of total) of Russian Federation in 2001?
Make the answer very short. 25.35. What is the difference between the Electricity production(% of total) in Pakistan in 1998 and the Electricity production(% of total) in Russian Federation in 2001?
Offer a terse response. 14.76. What is the difference between the Electricity production(% of total) of Euro area in 1999 and the Electricity production(% of total) of Chile in 2000?
Keep it short and to the point. -34.45. What is the difference between the Electricity production(% of total) of Euro area in 1999 and the Electricity production(% of total) of Pakistan in 2000?
Your response must be concise. -13.49. What is the difference between the Electricity production(% of total) in Euro area in 1999 and the Electricity production(% of total) in Russian Federation in 2000?
Give a very brief answer. -6.97. What is the difference between the Electricity production(% of total) of Chile in 1999 and the Electricity production(% of total) of Pakistan in 2000?
Make the answer very short. 10.16. What is the difference between the Electricity production(% of total) in Chile in 1999 and the Electricity production(% of total) in Russian Federation in 2000?
Give a very brief answer. 16.68. What is the difference between the Electricity production(% of total) in Pakistan in 1999 and the Electricity production(% of total) in Russian Federation in 2000?
Give a very brief answer. 10.6. What is the difference between the Electricity production(% of total) in Euro area in 1999 and the Electricity production(% of total) in Chile in 2001?
Your answer should be compact. -37.63. What is the difference between the Electricity production(% of total) of Euro area in 1999 and the Electricity production(% of total) of Pakistan in 2001?
Your answer should be very brief. -14.4. What is the difference between the Electricity production(% of total) in Euro area in 1999 and the Electricity production(% of total) in Russian Federation in 2001?
Give a very brief answer. -7.8. What is the difference between the Electricity production(% of total) in Chile in 1999 and the Electricity production(% of total) in Pakistan in 2001?
Your answer should be compact. 9.25. What is the difference between the Electricity production(% of total) of Chile in 1999 and the Electricity production(% of total) of Russian Federation in 2001?
Provide a short and direct response. 15.85. What is the difference between the Electricity production(% of total) in Pakistan in 1999 and the Electricity production(% of total) in Russian Federation in 2001?
Give a very brief answer. 9.77. What is the difference between the Electricity production(% of total) in Euro area in 2000 and the Electricity production(% of total) in Chile in 2001?
Your answer should be compact. -37.67. What is the difference between the Electricity production(% of total) of Euro area in 2000 and the Electricity production(% of total) of Pakistan in 2001?
Offer a very short reply. -14.44. What is the difference between the Electricity production(% of total) of Euro area in 2000 and the Electricity production(% of total) of Russian Federation in 2001?
Keep it short and to the point. -7.84. What is the difference between the Electricity production(% of total) of Chile in 2000 and the Electricity production(% of total) of Pakistan in 2001?
Your answer should be very brief. 20.05. What is the difference between the Electricity production(% of total) in Chile in 2000 and the Electricity production(% of total) in Russian Federation in 2001?
Keep it short and to the point. 26.65. What is the difference between the Electricity production(% of total) in Pakistan in 2000 and the Electricity production(% of total) in Russian Federation in 2001?
Offer a terse response. 5.69. What is the average Electricity production(% of total) in Euro area per year?
Offer a very short reply. 12.31. What is the average Electricity production(% of total) of Chile per year?
Offer a very short reply. 52.56. What is the average Electricity production(% of total) in Pakistan per year?
Offer a terse response. 33.65. What is the average Electricity production(% of total) of Russian Federation per year?
Keep it short and to the point. 19.22. In the year 1994, what is the difference between the Electricity production(% of total) in Euro area and Electricity production(% of total) in Chile?
Offer a terse response. -53.7. In the year 1994, what is the difference between the Electricity production(% of total) of Euro area and Electricity production(% of total) of Pakistan?
Provide a short and direct response. -29.18. In the year 1994, what is the difference between the Electricity production(% of total) of Euro area and Electricity production(% of total) of Russian Federation?
Make the answer very short. -6.5. In the year 1994, what is the difference between the Electricity production(% of total) of Chile and Electricity production(% of total) of Pakistan?
Your answer should be very brief. 24.52. In the year 1994, what is the difference between the Electricity production(% of total) in Chile and Electricity production(% of total) in Russian Federation?
Offer a terse response. 47.2. In the year 1994, what is the difference between the Electricity production(% of total) in Pakistan and Electricity production(% of total) in Russian Federation?
Your response must be concise. 22.68. In the year 1995, what is the difference between the Electricity production(% of total) of Euro area and Electricity production(% of total) of Chile?
Offer a terse response. -53.38. In the year 1995, what is the difference between the Electricity production(% of total) in Euro area and Electricity production(% of total) in Pakistan?
Your answer should be very brief. -28.42. In the year 1995, what is the difference between the Electricity production(% of total) of Euro area and Electricity production(% of total) of Russian Federation?
Provide a short and direct response. -8.1. In the year 1995, what is the difference between the Electricity production(% of total) in Chile and Electricity production(% of total) in Pakistan?
Your answer should be very brief. 24.96. In the year 1995, what is the difference between the Electricity production(% of total) of Chile and Electricity production(% of total) of Russian Federation?
Ensure brevity in your answer.  45.28. In the year 1995, what is the difference between the Electricity production(% of total) in Pakistan and Electricity production(% of total) in Russian Federation?
Offer a terse response. 20.32. In the year 1996, what is the difference between the Electricity production(% of total) in Euro area and Electricity production(% of total) in Chile?
Your answer should be compact. -42.02. In the year 1996, what is the difference between the Electricity production(% of total) in Euro area and Electricity production(% of total) in Pakistan?
Keep it short and to the point. -22.5. In the year 1996, what is the difference between the Electricity production(% of total) in Euro area and Electricity production(% of total) in Russian Federation?
Provide a succinct answer. -5.34. In the year 1996, what is the difference between the Electricity production(% of total) in Chile and Electricity production(% of total) in Pakistan?
Provide a succinct answer. 19.52. In the year 1996, what is the difference between the Electricity production(% of total) of Chile and Electricity production(% of total) of Russian Federation?
Offer a terse response. 36.68. In the year 1996, what is the difference between the Electricity production(% of total) of Pakistan and Electricity production(% of total) of Russian Federation?
Provide a succinct answer. 17.16. In the year 1997, what is the difference between the Electricity production(% of total) in Euro area and Electricity production(% of total) in Chile?
Ensure brevity in your answer.  -44.86. In the year 1997, what is the difference between the Electricity production(% of total) of Euro area and Electricity production(% of total) of Pakistan?
Provide a short and direct response. -23.45. In the year 1997, what is the difference between the Electricity production(% of total) in Euro area and Electricity production(% of total) in Russian Federation?
Provide a short and direct response. -6.75. In the year 1997, what is the difference between the Electricity production(% of total) in Chile and Electricity production(% of total) in Pakistan?
Offer a very short reply. 21.41. In the year 1997, what is the difference between the Electricity production(% of total) in Chile and Electricity production(% of total) in Russian Federation?
Offer a very short reply. 38.11. In the year 1997, what is the difference between the Electricity production(% of total) of Pakistan and Electricity production(% of total) of Russian Federation?
Keep it short and to the point. 16.7. In the year 1998, what is the difference between the Electricity production(% of total) of Euro area and Electricity production(% of total) of Chile?
Offer a very short reply. -32.98. In the year 1998, what is the difference between the Electricity production(% of total) of Euro area and Electricity production(% of total) of Pakistan?
Your answer should be compact. -22.39. In the year 1998, what is the difference between the Electricity production(% of total) in Euro area and Electricity production(% of total) in Russian Federation?
Offer a very short reply. -7.27. In the year 1998, what is the difference between the Electricity production(% of total) of Chile and Electricity production(% of total) of Pakistan?
Ensure brevity in your answer.  10.59. In the year 1998, what is the difference between the Electricity production(% of total) of Chile and Electricity production(% of total) of Russian Federation?
Provide a short and direct response. 25.72. In the year 1998, what is the difference between the Electricity production(% of total) in Pakistan and Electricity production(% of total) in Russian Federation?
Your answer should be compact. 15.13. In the year 1999, what is the difference between the Electricity production(% of total) in Euro area and Electricity production(% of total) in Chile?
Provide a short and direct response. -23.65. In the year 1999, what is the difference between the Electricity production(% of total) in Euro area and Electricity production(% of total) in Pakistan?
Offer a terse response. -17.57. In the year 1999, what is the difference between the Electricity production(% of total) of Euro area and Electricity production(% of total) of Russian Federation?
Ensure brevity in your answer.  -7.23. In the year 1999, what is the difference between the Electricity production(% of total) of Chile and Electricity production(% of total) of Pakistan?
Your answer should be compact. 6.08. In the year 1999, what is the difference between the Electricity production(% of total) of Chile and Electricity production(% of total) of Russian Federation?
Offer a very short reply. 16.41. In the year 1999, what is the difference between the Electricity production(% of total) in Pakistan and Electricity production(% of total) in Russian Federation?
Ensure brevity in your answer.  10.34. In the year 2000, what is the difference between the Electricity production(% of total) in Euro area and Electricity production(% of total) in Chile?
Keep it short and to the point. -34.49. In the year 2000, what is the difference between the Electricity production(% of total) in Euro area and Electricity production(% of total) in Pakistan?
Keep it short and to the point. -13.53. In the year 2000, what is the difference between the Electricity production(% of total) in Euro area and Electricity production(% of total) in Russian Federation?
Offer a very short reply. -7.01. In the year 2000, what is the difference between the Electricity production(% of total) in Chile and Electricity production(% of total) in Pakistan?
Offer a terse response. 20.96. In the year 2000, what is the difference between the Electricity production(% of total) of Chile and Electricity production(% of total) of Russian Federation?
Make the answer very short. 27.48. In the year 2000, what is the difference between the Electricity production(% of total) in Pakistan and Electricity production(% of total) in Russian Federation?
Keep it short and to the point. 6.52. In the year 2001, what is the difference between the Electricity production(% of total) of Euro area and Electricity production(% of total) of Chile?
Provide a short and direct response. -36.91. In the year 2001, what is the difference between the Electricity production(% of total) of Euro area and Electricity production(% of total) of Pakistan?
Give a very brief answer. -13.68. In the year 2001, what is the difference between the Electricity production(% of total) in Euro area and Electricity production(% of total) in Russian Federation?
Offer a terse response. -7.08. In the year 2001, what is the difference between the Electricity production(% of total) of Chile and Electricity production(% of total) of Pakistan?
Your answer should be very brief. 23.23. In the year 2001, what is the difference between the Electricity production(% of total) of Chile and Electricity production(% of total) of Russian Federation?
Your answer should be very brief. 29.83. In the year 2001, what is the difference between the Electricity production(% of total) of Pakistan and Electricity production(% of total) of Russian Federation?
Provide a short and direct response. 6.6. What is the ratio of the Electricity production(% of total) of Euro area in 1994 to that in 1995?
Offer a terse response. 1.1. What is the ratio of the Electricity production(% of total) of Chile in 1994 to that in 1995?
Your answer should be compact. 1.02. What is the ratio of the Electricity production(% of total) in Pakistan in 1994 to that in 1995?
Make the answer very short. 1.05. What is the ratio of the Electricity production(% of total) in Russian Federation in 1994 to that in 1995?
Offer a very short reply. 0.98. What is the ratio of the Electricity production(% of total) in Euro area in 1994 to that in 1996?
Keep it short and to the point. 1.06. What is the ratio of the Electricity production(% of total) in Chile in 1994 to that in 1996?
Your response must be concise. 1.23. What is the ratio of the Electricity production(% of total) of Pakistan in 1994 to that in 1996?
Give a very brief answer. 1.21. What is the ratio of the Electricity production(% of total) in Russian Federation in 1994 to that in 1996?
Ensure brevity in your answer.  1.1. What is the ratio of the Electricity production(% of total) of Euro area in 1994 to that in 1997?
Offer a very short reply. 1.12. What is the ratio of the Electricity production(% of total) of Chile in 1994 to that in 1997?
Provide a succinct answer. 1.18. What is the ratio of the Electricity production(% of total) of Pakistan in 1994 to that in 1997?
Offer a terse response. 1.2. What is the ratio of the Electricity production(% of total) of Russian Federation in 1994 to that in 1997?
Provide a succinct answer. 1.06. What is the ratio of the Electricity production(% of total) in Euro area in 1994 to that in 1998?
Ensure brevity in your answer.  1.13. What is the ratio of the Electricity production(% of total) in Chile in 1994 to that in 1998?
Keep it short and to the point. 1.5. What is the ratio of the Electricity production(% of total) in Pakistan in 1994 to that in 1998?
Your answer should be compact. 1.24. What is the ratio of the Electricity production(% of total) in Russian Federation in 1994 to that in 1998?
Offer a very short reply. 1.04. What is the ratio of the Electricity production(% of total) of Euro area in 1994 to that in 1999?
Give a very brief answer. 1.15. What is the ratio of the Electricity production(% of total) of Chile in 1994 to that in 1999?
Offer a very short reply. 1.9. What is the ratio of the Electricity production(% of total) in Pakistan in 1994 to that in 1999?
Make the answer very short. 1.46. What is the ratio of the Electricity production(% of total) of Russian Federation in 1994 to that in 1999?
Give a very brief answer. 1.05. What is the ratio of the Electricity production(% of total) of Euro area in 1994 to that in 2000?
Give a very brief answer. 1.15. What is the ratio of the Electricity production(% of total) in Chile in 1994 to that in 2000?
Give a very brief answer. 1.45. What is the ratio of the Electricity production(% of total) of Pakistan in 1994 to that in 2000?
Give a very brief answer. 1.69. What is the ratio of the Electricity production(% of total) of Russian Federation in 1994 to that in 2000?
Keep it short and to the point. 1.07. What is the ratio of the Electricity production(% of total) in Euro area in 1994 to that in 2001?
Keep it short and to the point. 1.08. What is the ratio of the Electricity production(% of total) of Chile in 1994 to that in 2001?
Ensure brevity in your answer.  1.36. What is the ratio of the Electricity production(% of total) of Pakistan in 1994 to that in 2001?
Give a very brief answer. 1.63. What is the ratio of the Electricity production(% of total) of Russian Federation in 1994 to that in 2001?
Keep it short and to the point. 1.02. What is the ratio of the Electricity production(% of total) of Euro area in 1995 to that in 1996?
Offer a terse response. 0.96. What is the ratio of the Electricity production(% of total) of Chile in 1995 to that in 1996?
Give a very brief answer. 1.2. What is the ratio of the Electricity production(% of total) in Pakistan in 1995 to that in 1996?
Ensure brevity in your answer.  1.15. What is the ratio of the Electricity production(% of total) in Russian Federation in 1995 to that in 1996?
Offer a very short reply. 1.13. What is the ratio of the Electricity production(% of total) in Euro area in 1995 to that in 1997?
Ensure brevity in your answer.  1.02. What is the ratio of the Electricity production(% of total) in Chile in 1995 to that in 1997?
Provide a short and direct response. 1.15. What is the ratio of the Electricity production(% of total) in Pakistan in 1995 to that in 1997?
Offer a very short reply. 1.15. What is the ratio of the Electricity production(% of total) in Russian Federation in 1995 to that in 1997?
Ensure brevity in your answer.  1.09. What is the ratio of the Electricity production(% of total) of Euro area in 1995 to that in 1998?
Offer a terse response. 1.03. What is the ratio of the Electricity production(% of total) in Chile in 1995 to that in 1998?
Make the answer very short. 1.46. What is the ratio of the Electricity production(% of total) in Pakistan in 1995 to that in 1998?
Your response must be concise. 1.19. What is the ratio of the Electricity production(% of total) of Russian Federation in 1995 to that in 1998?
Give a very brief answer. 1.06. What is the ratio of the Electricity production(% of total) of Euro area in 1995 to that in 1999?
Offer a terse response. 1.05. What is the ratio of the Electricity production(% of total) in Chile in 1995 to that in 1999?
Make the answer very short. 1.86. What is the ratio of the Electricity production(% of total) of Pakistan in 1995 to that in 1999?
Give a very brief answer. 1.39. What is the ratio of the Electricity production(% of total) in Russian Federation in 1995 to that in 1999?
Make the answer very short. 1.08. What is the ratio of the Electricity production(% of total) of Euro area in 1995 to that in 2000?
Offer a terse response. 1.05. What is the ratio of the Electricity production(% of total) of Chile in 1995 to that in 2000?
Keep it short and to the point. 1.42. What is the ratio of the Electricity production(% of total) of Pakistan in 1995 to that in 2000?
Provide a succinct answer. 1.61. What is the ratio of the Electricity production(% of total) of Russian Federation in 1995 to that in 2000?
Your answer should be very brief. 1.09. What is the ratio of the Electricity production(% of total) in Euro area in 1995 to that in 2001?
Provide a short and direct response. 0.99. What is the ratio of the Electricity production(% of total) in Chile in 1995 to that in 2001?
Provide a short and direct response. 1.33. What is the ratio of the Electricity production(% of total) of Pakistan in 1995 to that in 2001?
Give a very brief answer. 1.56. What is the ratio of the Electricity production(% of total) of Russian Federation in 1995 to that in 2001?
Keep it short and to the point. 1.04. What is the ratio of the Electricity production(% of total) of Euro area in 1996 to that in 1997?
Offer a terse response. 1.06. What is the ratio of the Electricity production(% of total) of Chile in 1996 to that in 1997?
Offer a terse response. 0.96. What is the ratio of the Electricity production(% of total) of Russian Federation in 1996 to that in 1997?
Provide a short and direct response. 0.96. What is the ratio of the Electricity production(% of total) of Euro area in 1996 to that in 1998?
Make the answer very short. 1.07. What is the ratio of the Electricity production(% of total) of Chile in 1996 to that in 1998?
Offer a very short reply. 1.22. What is the ratio of the Electricity production(% of total) in Pakistan in 1996 to that in 1998?
Keep it short and to the point. 1.03. What is the ratio of the Electricity production(% of total) of Russian Federation in 1996 to that in 1998?
Your answer should be compact. 0.94. What is the ratio of the Electricity production(% of total) of Euro area in 1996 to that in 1999?
Give a very brief answer. 1.09. What is the ratio of the Electricity production(% of total) of Chile in 1996 to that in 1999?
Offer a very short reply. 1.55. What is the ratio of the Electricity production(% of total) in Pakistan in 1996 to that in 1999?
Make the answer very short. 1.2. What is the ratio of the Electricity production(% of total) of Russian Federation in 1996 to that in 1999?
Keep it short and to the point. 0.95. What is the ratio of the Electricity production(% of total) in Euro area in 1996 to that in 2000?
Keep it short and to the point. 1.09. What is the ratio of the Electricity production(% of total) of Chile in 1996 to that in 2000?
Provide a short and direct response. 1.19. What is the ratio of the Electricity production(% of total) of Pakistan in 1996 to that in 2000?
Provide a short and direct response. 1.4. What is the ratio of the Electricity production(% of total) of Russian Federation in 1996 to that in 2000?
Offer a very short reply. 0.97. What is the ratio of the Electricity production(% of total) in Euro area in 1996 to that in 2001?
Offer a terse response. 1.02. What is the ratio of the Electricity production(% of total) in Chile in 1996 to that in 2001?
Provide a short and direct response. 1.11. What is the ratio of the Electricity production(% of total) in Pakistan in 1996 to that in 2001?
Keep it short and to the point. 1.35. What is the ratio of the Electricity production(% of total) of Russian Federation in 1996 to that in 2001?
Keep it short and to the point. 0.93. What is the ratio of the Electricity production(% of total) of Euro area in 1997 to that in 1998?
Make the answer very short. 1.01. What is the ratio of the Electricity production(% of total) of Chile in 1997 to that in 1998?
Offer a very short reply. 1.27. What is the ratio of the Electricity production(% of total) of Pakistan in 1997 to that in 1998?
Offer a very short reply. 1.03. What is the ratio of the Electricity production(% of total) of Russian Federation in 1997 to that in 1998?
Your response must be concise. 0.98. What is the ratio of the Electricity production(% of total) of Euro area in 1997 to that in 1999?
Provide a succinct answer. 1.02. What is the ratio of the Electricity production(% of total) of Chile in 1997 to that in 1999?
Make the answer very short. 1.61. What is the ratio of the Electricity production(% of total) of Pakistan in 1997 to that in 1999?
Your answer should be very brief. 1.21. What is the ratio of the Electricity production(% of total) in Euro area in 1997 to that in 2000?
Your answer should be very brief. 1.03. What is the ratio of the Electricity production(% of total) of Chile in 1997 to that in 2000?
Ensure brevity in your answer.  1.23. What is the ratio of the Electricity production(% of total) of Pakistan in 1997 to that in 2000?
Provide a short and direct response. 1.41. What is the ratio of the Electricity production(% of total) of Russian Federation in 1997 to that in 2000?
Your response must be concise. 1. What is the ratio of the Electricity production(% of total) in Euro area in 1997 to that in 2001?
Offer a terse response. 0.97. What is the ratio of the Electricity production(% of total) of Chile in 1997 to that in 2001?
Your answer should be very brief. 1.15. What is the ratio of the Electricity production(% of total) of Pakistan in 1997 to that in 2001?
Keep it short and to the point. 1.36. What is the ratio of the Electricity production(% of total) in Russian Federation in 1997 to that in 2001?
Ensure brevity in your answer.  0.96. What is the ratio of the Electricity production(% of total) in Euro area in 1998 to that in 1999?
Keep it short and to the point. 1.01. What is the ratio of the Electricity production(% of total) of Chile in 1998 to that in 1999?
Provide a succinct answer. 1.27. What is the ratio of the Electricity production(% of total) of Pakistan in 1998 to that in 1999?
Your answer should be compact. 1.17. What is the ratio of the Electricity production(% of total) in Russian Federation in 1998 to that in 1999?
Ensure brevity in your answer.  1.01. What is the ratio of the Electricity production(% of total) of Euro area in 1998 to that in 2000?
Provide a short and direct response. 1.02. What is the ratio of the Electricity production(% of total) in Chile in 1998 to that in 2000?
Provide a short and direct response. 0.97. What is the ratio of the Electricity production(% of total) of Pakistan in 1998 to that in 2000?
Your answer should be compact. 1.36. What is the ratio of the Electricity production(% of total) of Russian Federation in 1998 to that in 2000?
Give a very brief answer. 1.02. What is the ratio of the Electricity production(% of total) in Euro area in 1998 to that in 2001?
Keep it short and to the point. 0.96. What is the ratio of the Electricity production(% of total) in Chile in 1998 to that in 2001?
Offer a very short reply. 0.91. What is the ratio of the Electricity production(% of total) of Pakistan in 1998 to that in 2001?
Offer a terse response. 1.31. What is the ratio of the Electricity production(% of total) of Russian Federation in 1998 to that in 2001?
Offer a very short reply. 0.98. What is the ratio of the Electricity production(% of total) in Euro area in 1999 to that in 2000?
Your response must be concise. 1. What is the ratio of the Electricity production(% of total) in Chile in 1999 to that in 2000?
Ensure brevity in your answer.  0.77. What is the ratio of the Electricity production(% of total) of Pakistan in 1999 to that in 2000?
Provide a short and direct response. 1.16. What is the ratio of the Electricity production(% of total) of Russian Federation in 1999 to that in 2000?
Your response must be concise. 1.01. What is the ratio of the Electricity production(% of total) of Euro area in 1999 to that in 2001?
Provide a short and direct response. 0.94. What is the ratio of the Electricity production(% of total) in Chile in 1999 to that in 2001?
Offer a very short reply. 0.72. What is the ratio of the Electricity production(% of total) of Pakistan in 1999 to that in 2001?
Your answer should be very brief. 1.12. What is the ratio of the Electricity production(% of total) of Russian Federation in 1999 to that in 2001?
Your answer should be compact. 0.97. What is the ratio of the Electricity production(% of total) in Euro area in 2000 to that in 2001?
Give a very brief answer. 0.94. What is the ratio of the Electricity production(% of total) in Chile in 2000 to that in 2001?
Make the answer very short. 0.94. What is the ratio of the Electricity production(% of total) of Pakistan in 2000 to that in 2001?
Offer a terse response. 0.97. What is the ratio of the Electricity production(% of total) in Russian Federation in 2000 to that in 2001?
Your response must be concise. 0.96. What is the difference between the highest and the second highest Electricity production(% of total) of Euro area?
Ensure brevity in your answer.  0.72. What is the difference between the highest and the second highest Electricity production(% of total) of Chile?
Your answer should be compact. 1.5. What is the difference between the highest and the second highest Electricity production(% of total) of Pakistan?
Provide a succinct answer. 1.94. What is the difference between the highest and the second highest Electricity production(% of total) in Russian Federation?
Your response must be concise. 0.42. What is the difference between the highest and the lowest Electricity production(% of total) in Euro area?
Keep it short and to the point. 1.79. What is the difference between the highest and the lowest Electricity production(% of total) in Chile?
Make the answer very short. 31.8. What is the difference between the highest and the lowest Electricity production(% of total) of Pakistan?
Your answer should be compact. 17.44. What is the difference between the highest and the lowest Electricity production(% of total) in Russian Federation?
Provide a succinct answer. 2.3. 